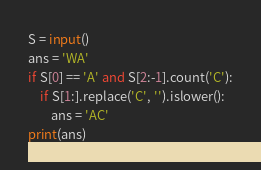Convert code to text. <code><loc_0><loc_0><loc_500><loc_500><_Python_>S = input()
ans = 'WA'
if S[0] == 'A' and S[2:-1].count('C'):
    if S[1:].replace('C', '').islower():
        ans = 'AC'
print(ans)</code> 